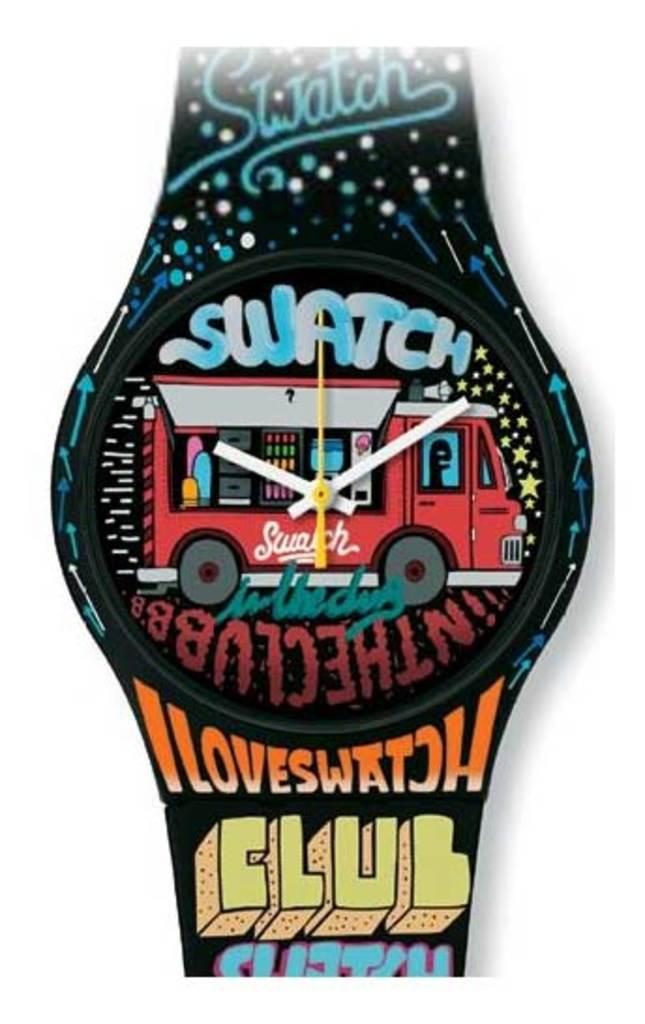<image>
Offer a succinct explanation of the picture presented. A picture of a watch that has Swatch on the face along with a food truck while the band says Iloveswatch club. 